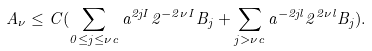Convert formula to latex. <formula><loc_0><loc_0><loc_500><loc_500>A _ { \nu } \leq C ( \sum _ { 0 \leq j \leq \nu c } a ^ { 2 j I } 2 ^ { - 2 \nu I } B _ { j } + \sum _ { j > \nu c } a ^ { - 2 j l } 2 ^ { 2 \nu l } B _ { j } ) .</formula> 